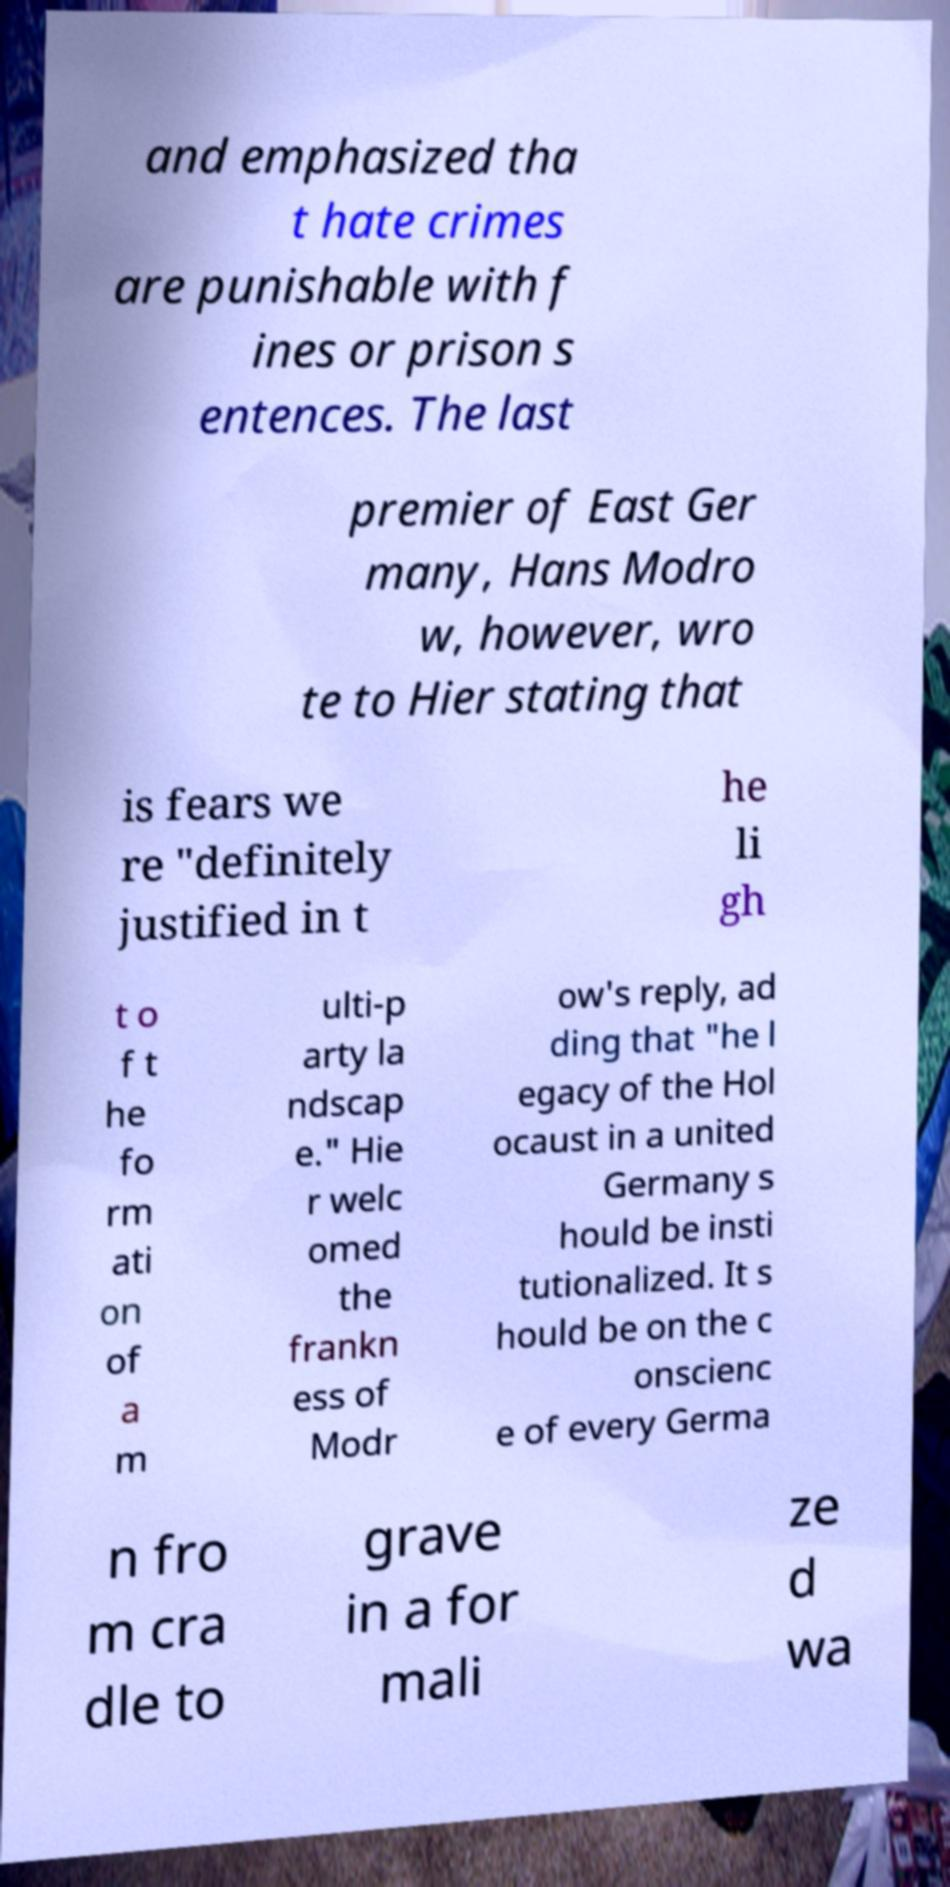Please read and relay the text visible in this image. What does it say? and emphasized tha t hate crimes are punishable with f ines or prison s entences. The last premier of East Ger many, Hans Modro w, however, wro te to Hier stating that is fears we re "definitely justified in t he li gh t o f t he fo rm ati on of a m ulti-p arty la ndscap e." Hie r welc omed the frankn ess of Modr ow's reply, ad ding that "he l egacy of the Hol ocaust in a united Germany s hould be insti tutionalized. It s hould be on the c onscienc e of every Germa n fro m cra dle to grave in a for mali ze d wa 